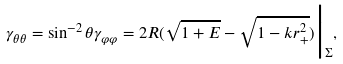<formula> <loc_0><loc_0><loc_500><loc_500>\gamma _ { \theta \theta } = \sin ^ { - 2 } \theta \gamma _ { \varphi \varphi } = 2 R ( \sqrt { 1 + E } - \sqrt { 1 - k r ^ { 2 } _ { + } } ) \Big | _ { \Sigma } ,</formula> 